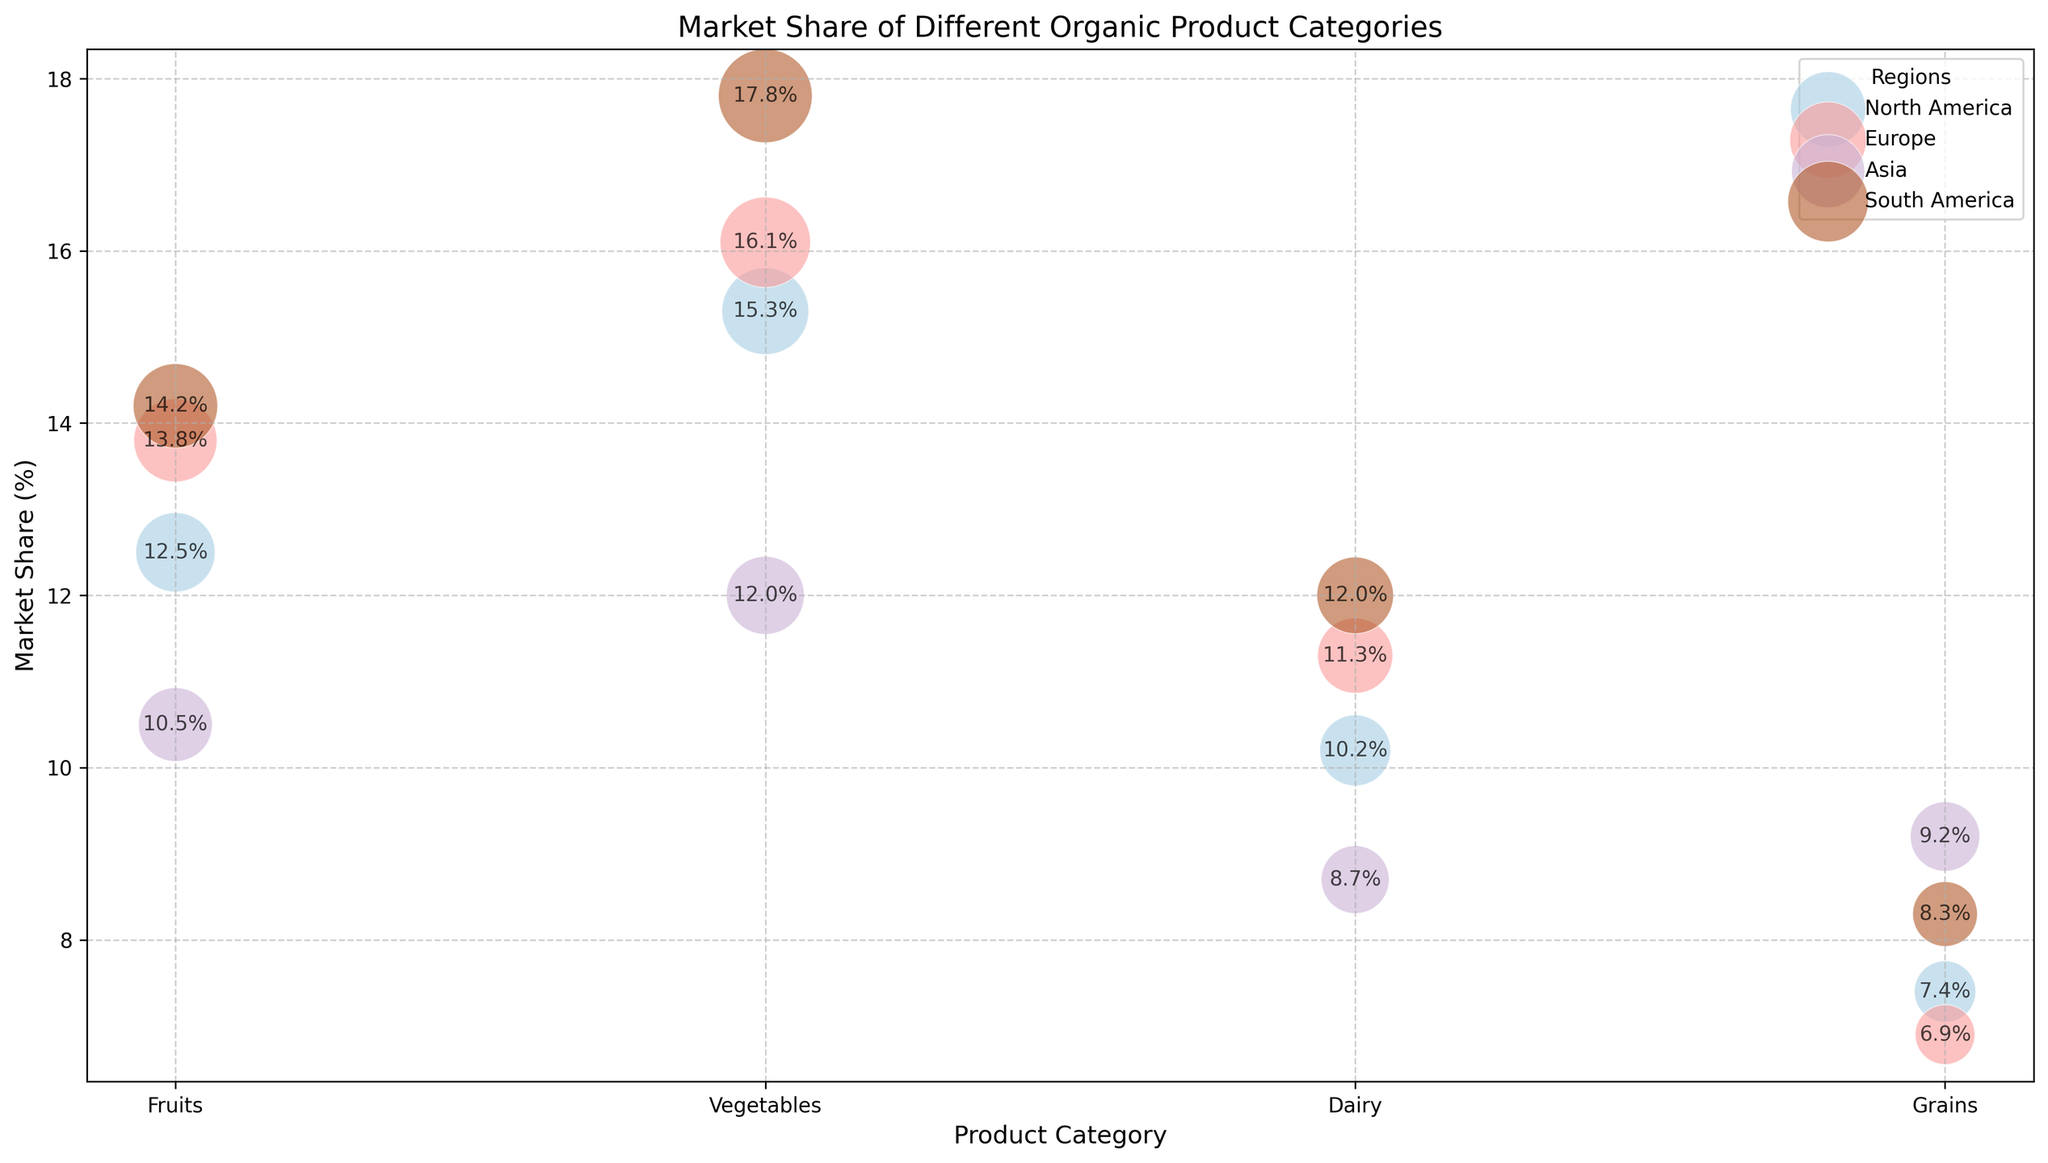Which region has the highest market share for vegetables? In the bubble chart, observe the vertical position of the bubbles labeled "Vegetables." The South America bubble is the highest on the y-axis, indicating the highest market share.
Answer: South America Which product category in North America has the lowest market share? Look at the bubbles under the "North America" color and identify the one with the lowest vertical position on the y-axis. The "Grains" bubble has the lowest position.
Answer: Grains What is the combined market share of dairy products across all regions? Sum the market shares for "Dairy" in North America (10.2%), Europe (11.3%), Asia (8.7%), and South America (12.0%). The combined total is 10.2 + 11.3 + 8.7 + 12.0.
Answer: 42.2% Which region has the largest volume for any product category, and what is the product? Identify the bubble with the largest size. The "Vegetables" bubble in South America is the largest.
Answer: South America, Vegetables What is the average market share for fruits across all regions? Sum the market shares for "Fruits" in each region (North America: 12.5%, Europe: 13.8%, Asia: 10.5%, South America: 14.2%) and divide by the number of regions (4). The average is (12.5 + 13.8 + 10.5 + 14.2) / 4.
Answer: 12.75% Which region has the most variations in market share among different product categories? Compare the range of market shares within each region by identifying the highest and lowest market shares in each. North America has the highest range: Vegetables (15.3%) to Grains (7.4%), so the range is 15.3 - 7.4.
Answer: North America Is there any product category where all regions have a market share greater than 10%? Check each product category to see if all regional bubbles have a vertical position above the 10% line. Only "Fruits" has all bubbles above 10%.
Answer: Fruits Which product category has the smallest volume in Europe? Look at the size of the bubbles under the "Europe" category and identify the smallest one. The "Grains" bubble is the smallest.
Answer: Grains What is the difference in market share between "Fruits" in North America and "Dairy" in Asia? Subtract the market share of "Dairy" in Asia (8.7%) from that of "Fruits" in North America (12.5%).
Answer: 3.8% Which region has a greater market share for grains, Europe or Asia? Compare the vertical positions of the "Grains" bubbles in Europe and Asia. Europe is at 6.9%, while Asia is at 9.2%.
Answer: Asia 